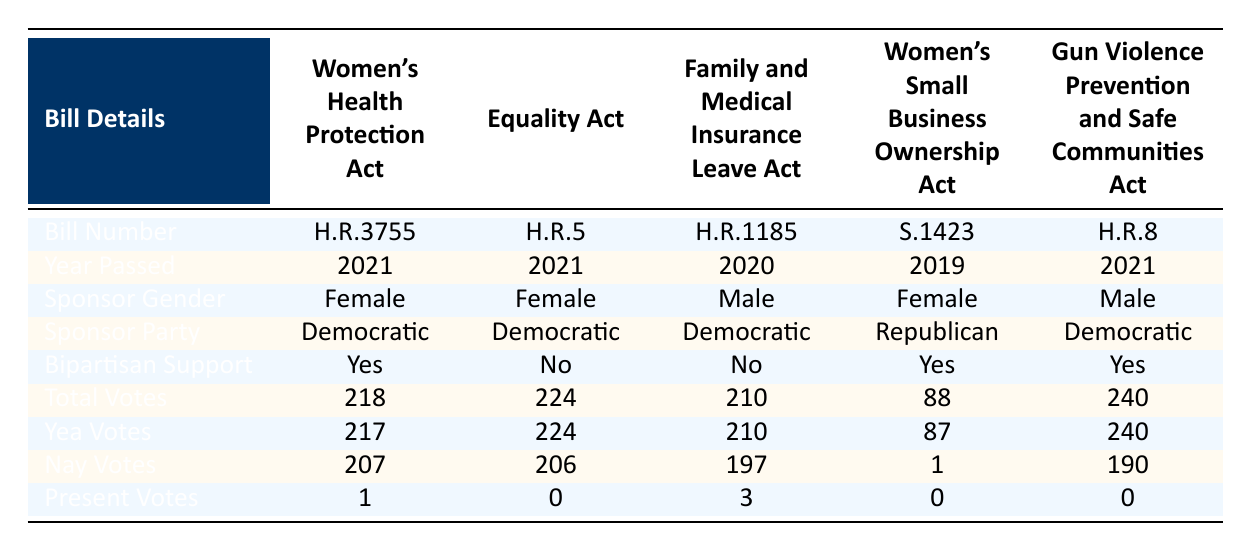What is the title of the bill with the highest total votes? The bill with the highest total votes is identified by looking at the "Total Votes" column. Among the bills, "Gun Violence Prevention and Safe Communities Act" has the highest total votes of 240.
Answer: Gun Violence Prevention and Safe Communities Act How many votes did the Women's Health Protection Act receive? The "Total Votes" column for the Women's Health Protection Act shows a total of 218 votes.
Answer: 218 Was the Equality Act sponsored by a female member of Congress? By checking the "Sponsor Gender" column for the Equality Act, it is confirmed that it was sponsored by a Female member of Congress.
Answer: Yes Which bill had the most bipartisan support? The "Bipartisan Support" column can be reviewed to find that three bills—Women's Health Protection Act, Women’s Small Business Ownership Act, and Gun Violence Prevention and Safe Communities Act—received bipartisan support (Yes). However, the question asks for the one with the most; since they are equally supported, it can be answered with any.
Answer: Women's Health Protection Act How many total votes were cast for bills sponsored by female legislators? To find the total votes for bills sponsored by female legislators, we look at the "Total Votes" for the Women's Health Protection Act (218), the Equality Act (224), and Women’s Small Business Ownership Act (88). Adding these gives 218 + 224 + 88 = 530.
Answer: 530 What percentage of the total votes for the Family and Medical Insurance Leave Act were 'Nay' votes? The "Total Votes" for the Family and Medical Insurance Leave Act is 210 with 197 'Nay' votes. To find the percentage, (197/210) * 100 ≈ 93.81%.
Answer: 93.81% Which bill had the fewest total votes? Comparing the "Total Votes" from the table, the "Women's Small Business Ownership Act" has the fewest total votes at 88.
Answer: Women's Small Business Ownership Act Did any bill receive a unanimous 'Yea' vote count? Checking the "Yea Votes" column, the Equality Act received all 224 votes as 'Yea', even though it faced 'Nay' votes from the opposition. Therefore, it can be read that while there are Nay votes, it was fully supported from the Democratic side.
Answer: No 